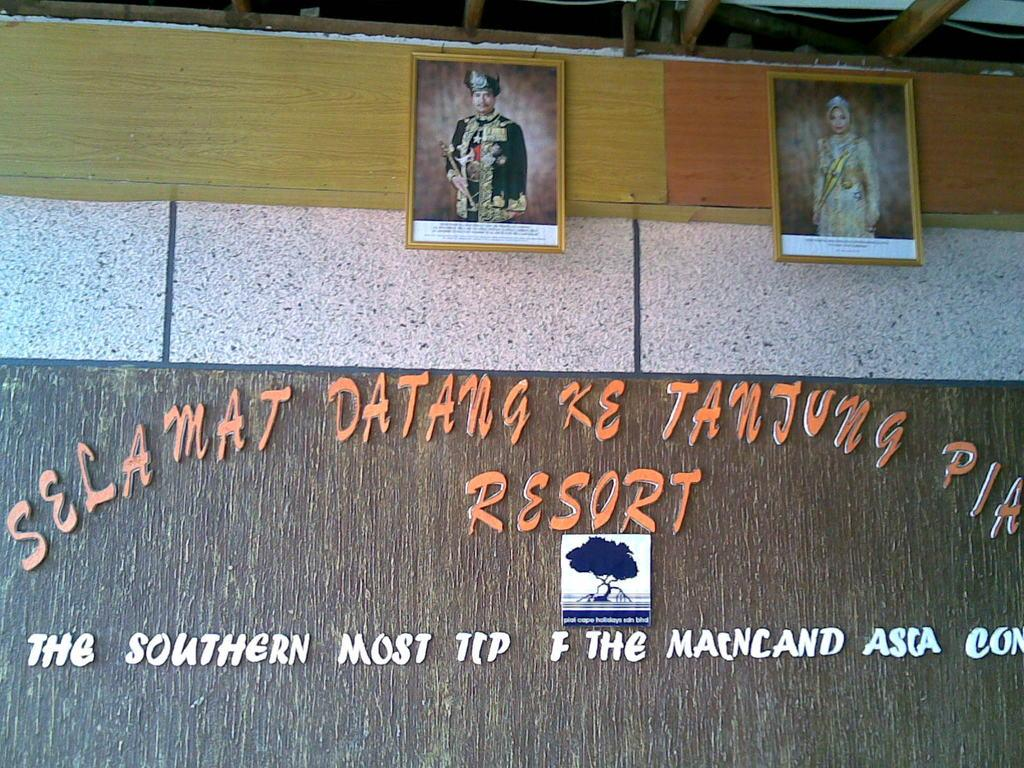What can be seen in the background of the image? There is a wall in the background of the image. What is attached to the wall? There are frames and a board on the wall. What is written or drawn on the wall? There is text on the wall. What is visible at the top of the image? There is a wire and wooden objects at the top of the image. What type of skirt is hanging from the wire at the top of the image? There is no skirt present in the image; only a wire and wooden objects are visible at the top of the image. 